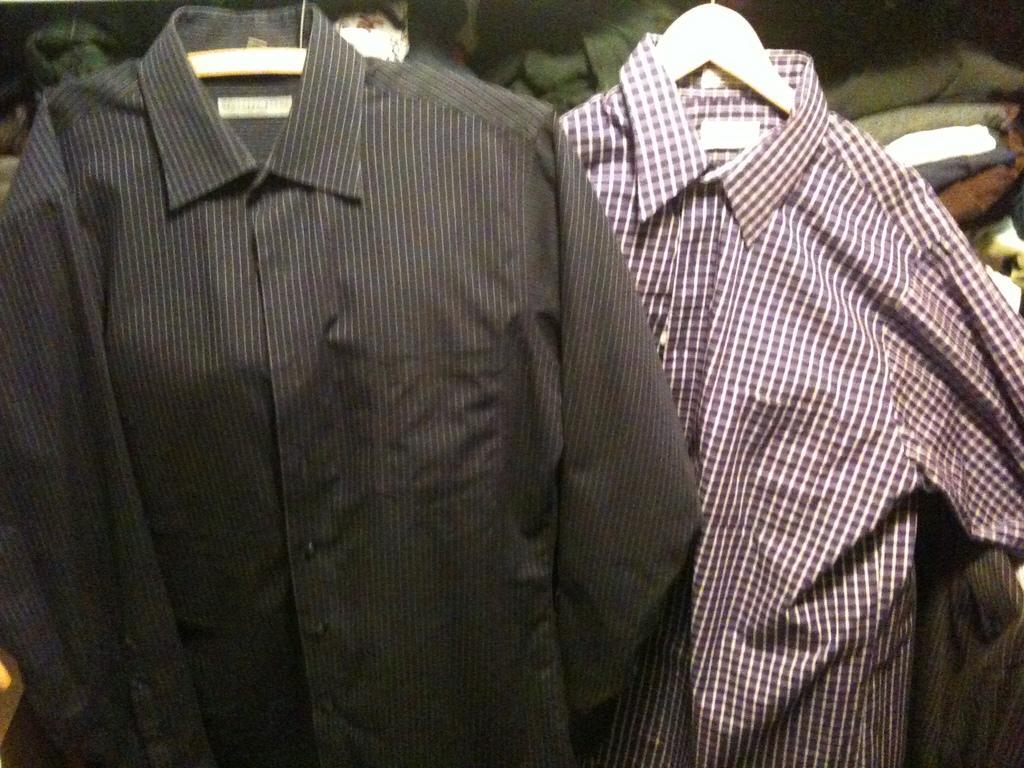Describe this image in one or two sentences. Here I can see two sheets to the hangers. In the background, I can see some more clothes. 